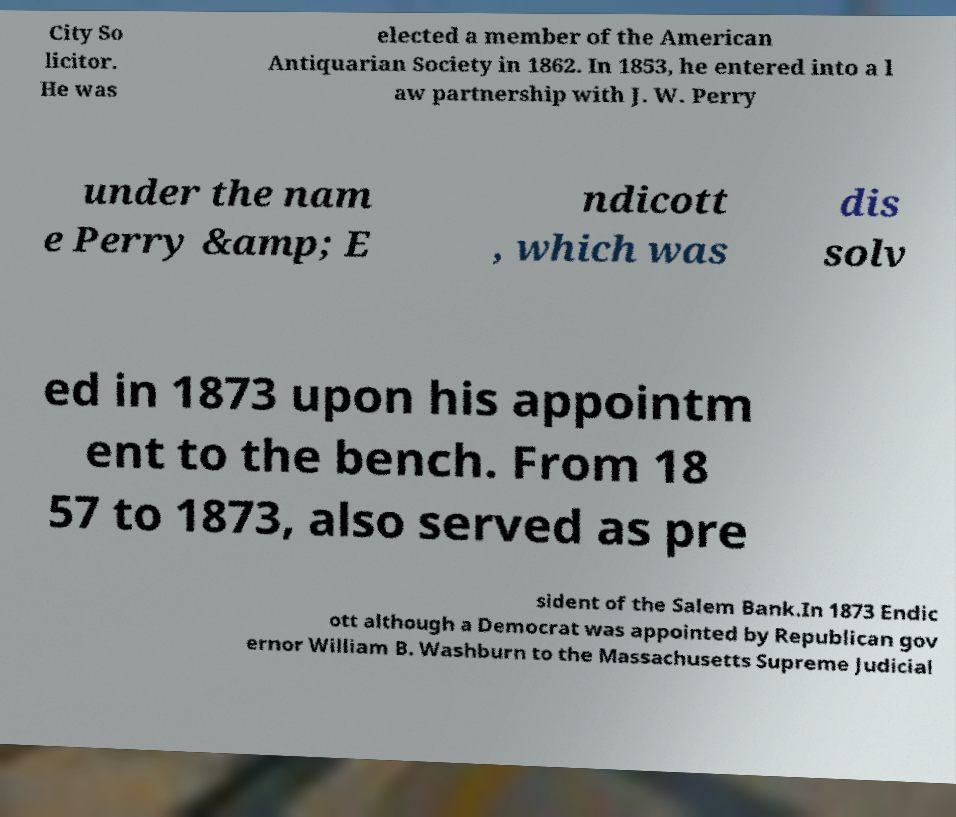Can you accurately transcribe the text from the provided image for me? City So licitor. He was elected a member of the American Antiquarian Society in 1862. In 1853, he entered into a l aw partnership with J. W. Perry under the nam e Perry &amp; E ndicott , which was dis solv ed in 1873 upon his appointm ent to the bench. From 18 57 to 1873, also served as pre sident of the Salem Bank.In 1873 Endic ott although a Democrat was appointed by Republican gov ernor William B. Washburn to the Massachusetts Supreme Judicial 